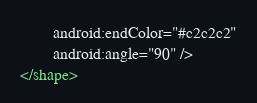<code> <loc_0><loc_0><loc_500><loc_500><_XML_>        android:endColor="#c2c2c2"
        android:angle="90" />
</shape>
</code> 